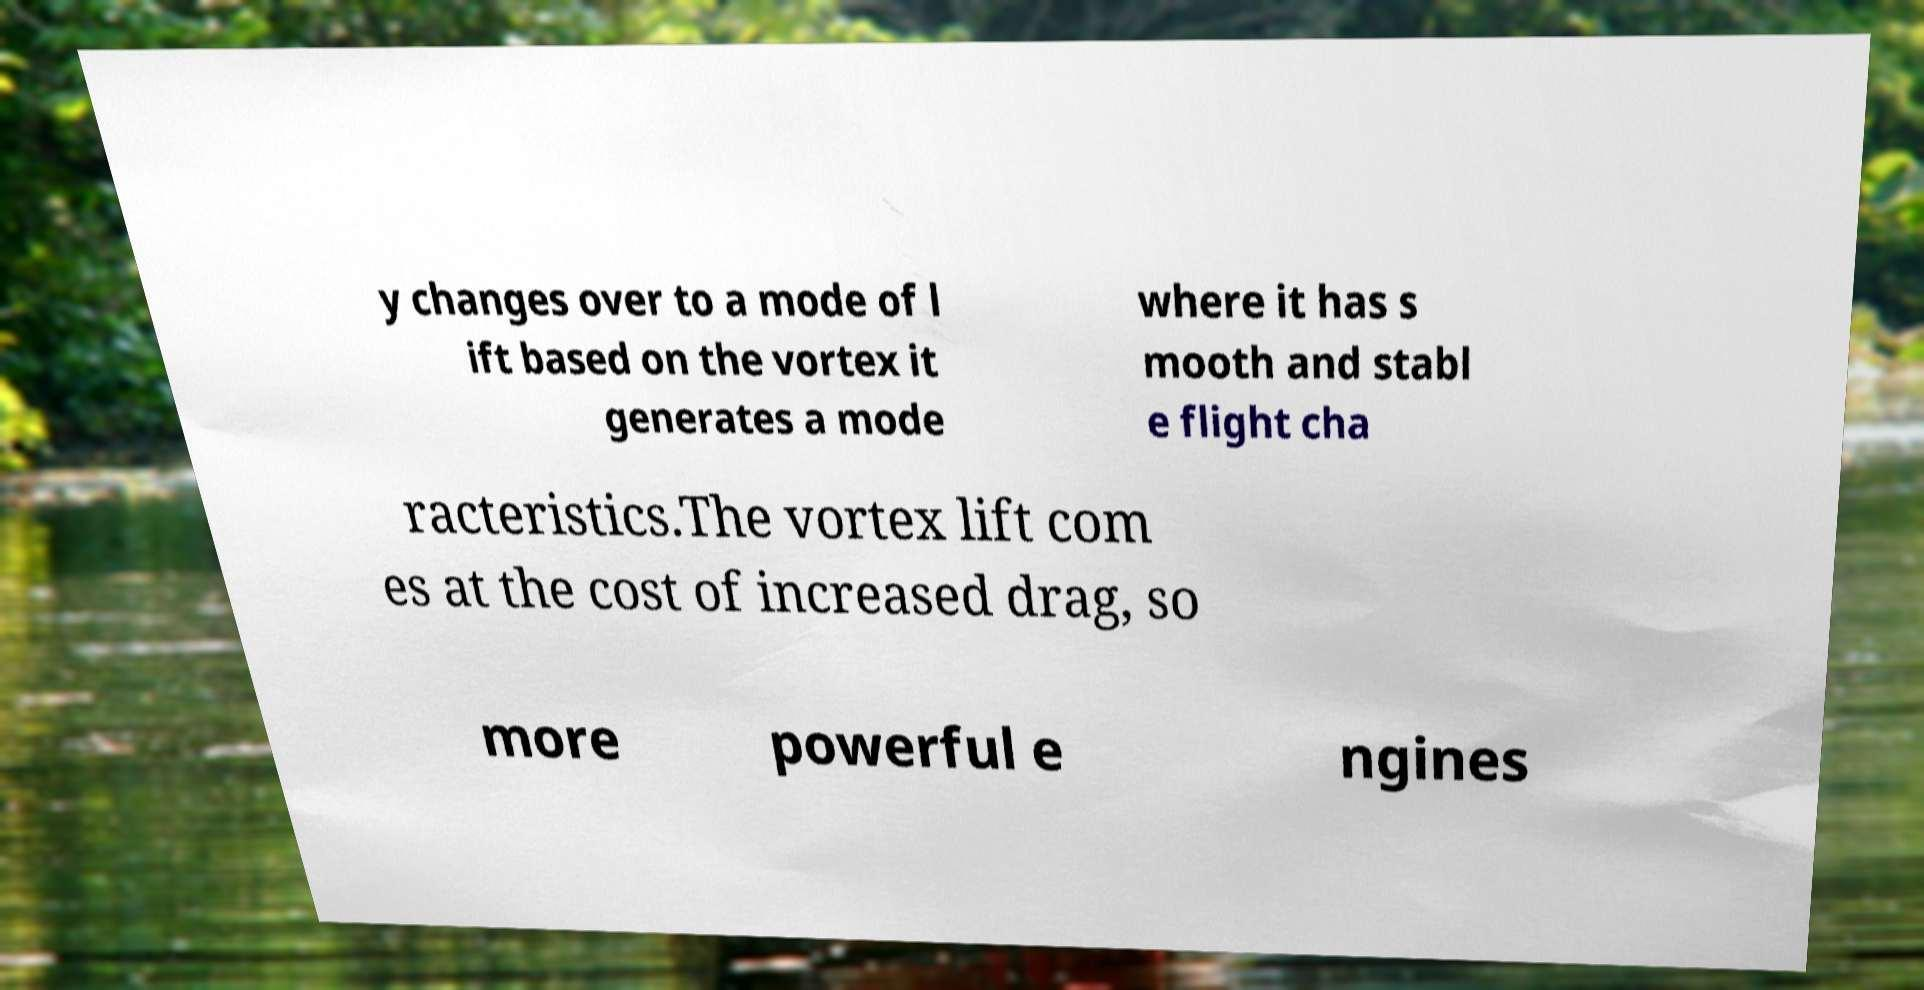For documentation purposes, I need the text within this image transcribed. Could you provide that? y changes over to a mode of l ift based on the vortex it generates a mode where it has s mooth and stabl e flight cha racteristics.The vortex lift com es at the cost of increased drag, so more powerful e ngines 